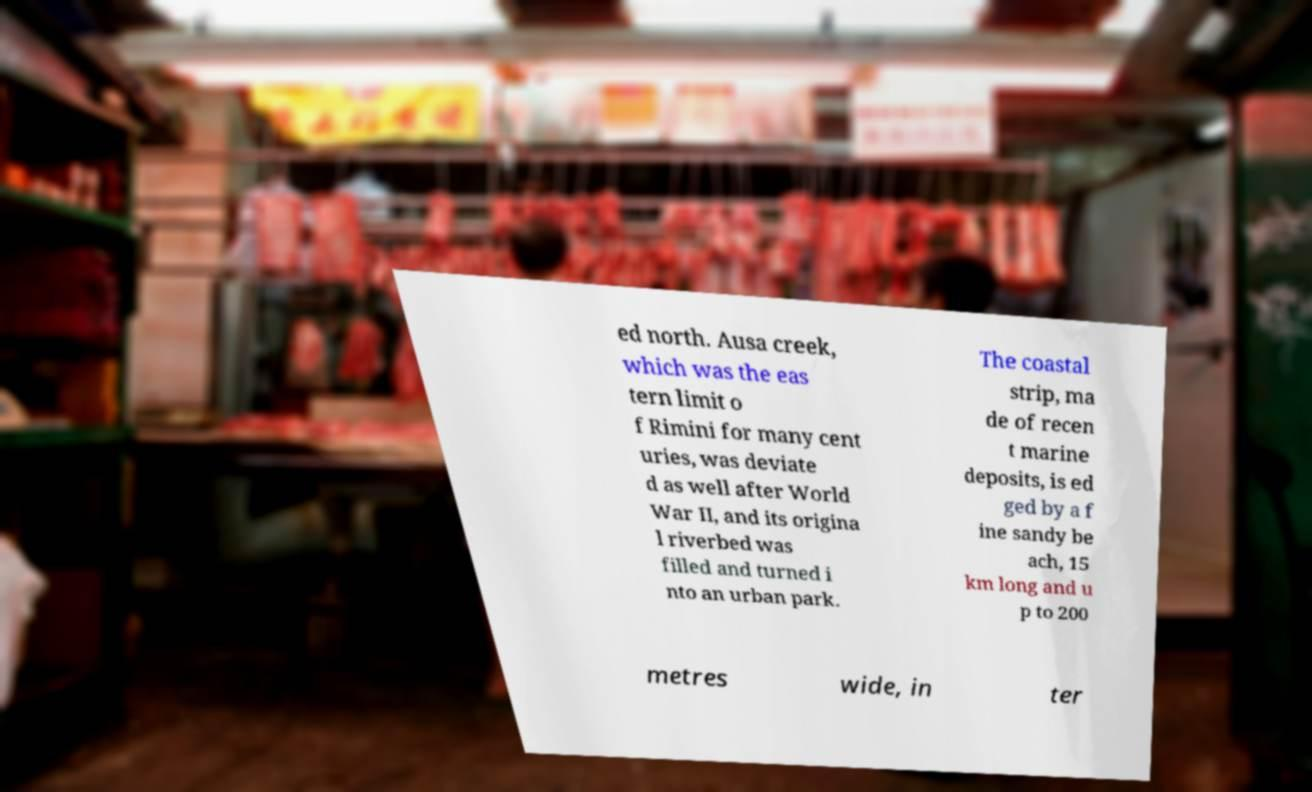Can you accurately transcribe the text from the provided image for me? ed north. Ausa creek, which was the eas tern limit o f Rimini for many cent uries, was deviate d as well after World War II, and its origina l riverbed was filled and turned i nto an urban park. The coastal strip, ma de of recen t marine deposits, is ed ged by a f ine sandy be ach, 15 km long and u p to 200 metres wide, in ter 